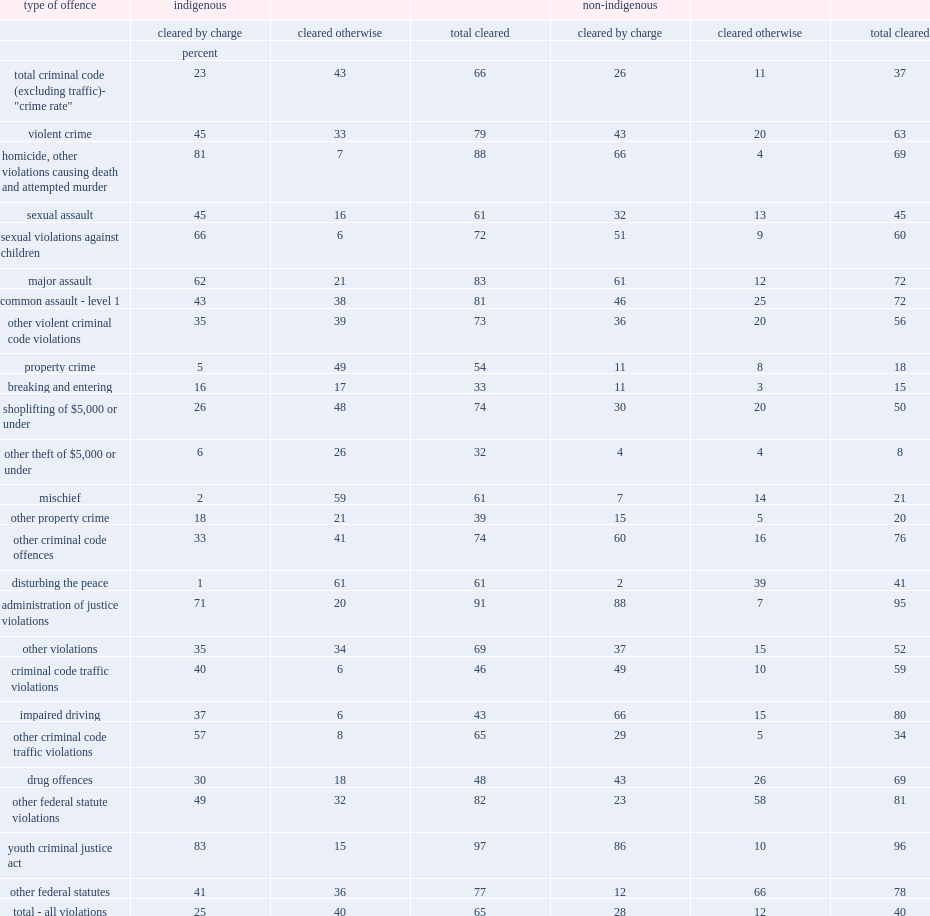How many percentage points have criminal incidents been cleared in indigenous communities in 2018? 66.0. How many percentage points have criminal incidents been cleared in indigenous communities in 2018? 37.0. 